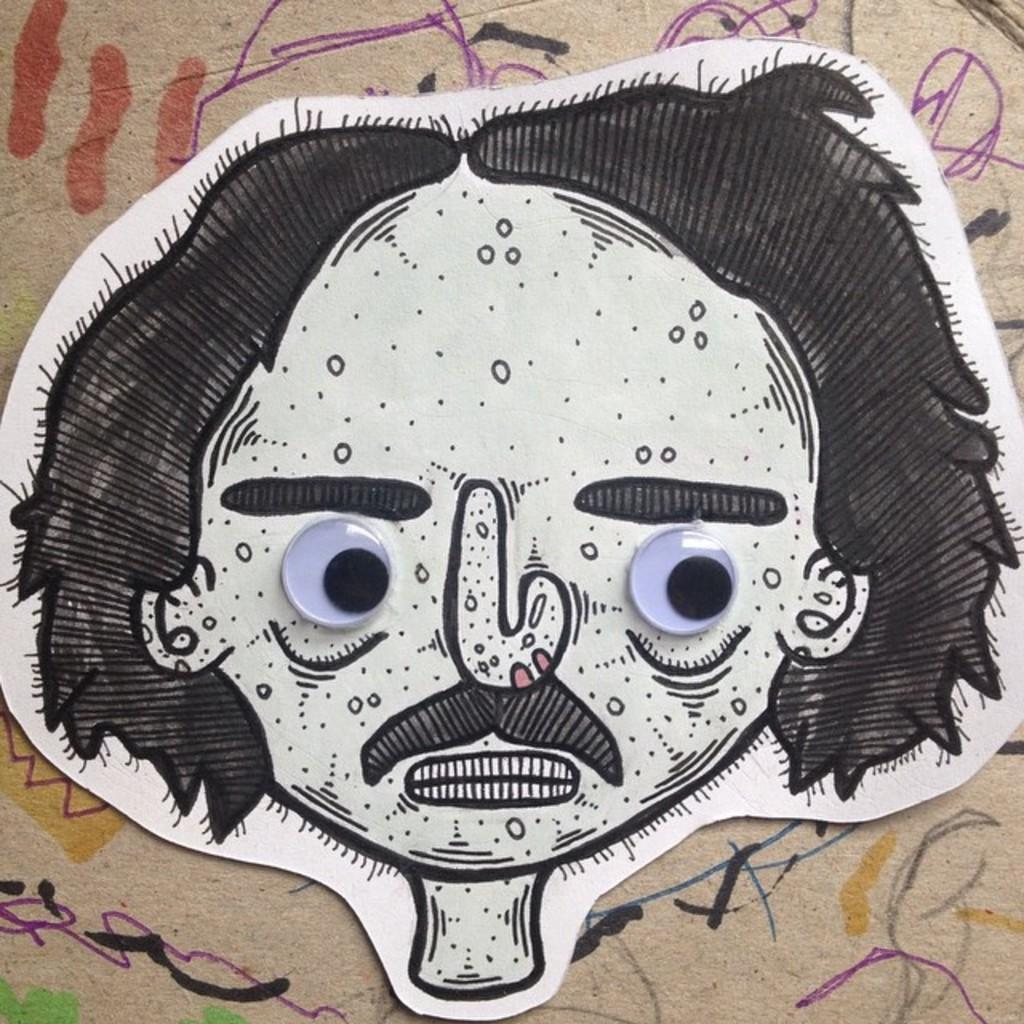What is depicted in the image? There is a drawing of a person in the image. What color is the drawing? The drawing is black in color. Where is the drawing located? The drawing is on a whiteboard. What is the background of the whiteboard? The whiteboard is placed on a painted surface. What type of bun is being used to draw the person in the image? There is no bun present in the image; it is a drawing on a whiteboard. What kind of border surrounds the drawing in the image? There is no border surrounding the drawing in the image; it is simply drawn on the whiteboard. 